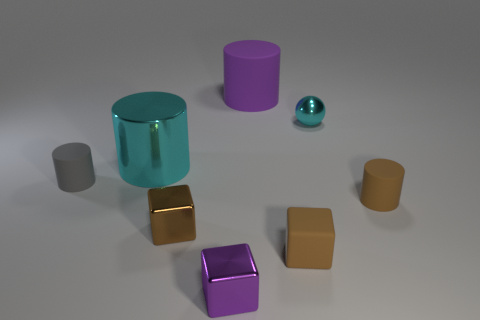What number of small objects are cylinders or matte blocks? 3 